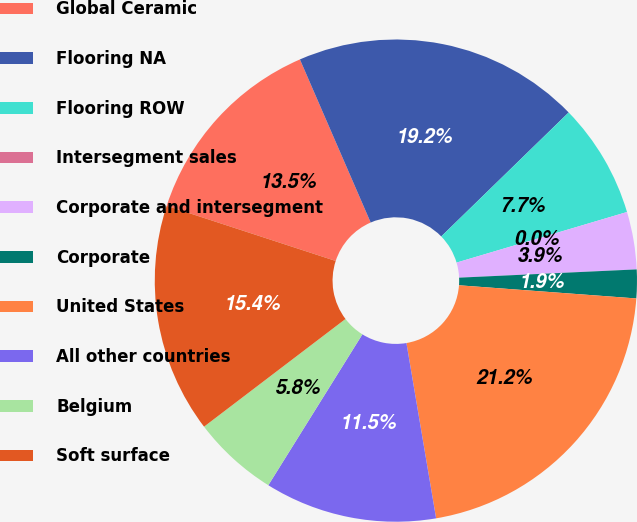Convert chart. <chart><loc_0><loc_0><loc_500><loc_500><pie_chart><fcel>Global Ceramic<fcel>Flooring NA<fcel>Flooring ROW<fcel>Intersegment sales<fcel>Corporate and intersegment<fcel>Corporate<fcel>United States<fcel>All other countries<fcel>Belgium<fcel>Soft surface<nl><fcel>13.46%<fcel>19.23%<fcel>7.69%<fcel>0.0%<fcel>3.85%<fcel>1.92%<fcel>21.15%<fcel>11.54%<fcel>5.77%<fcel>15.38%<nl></chart> 